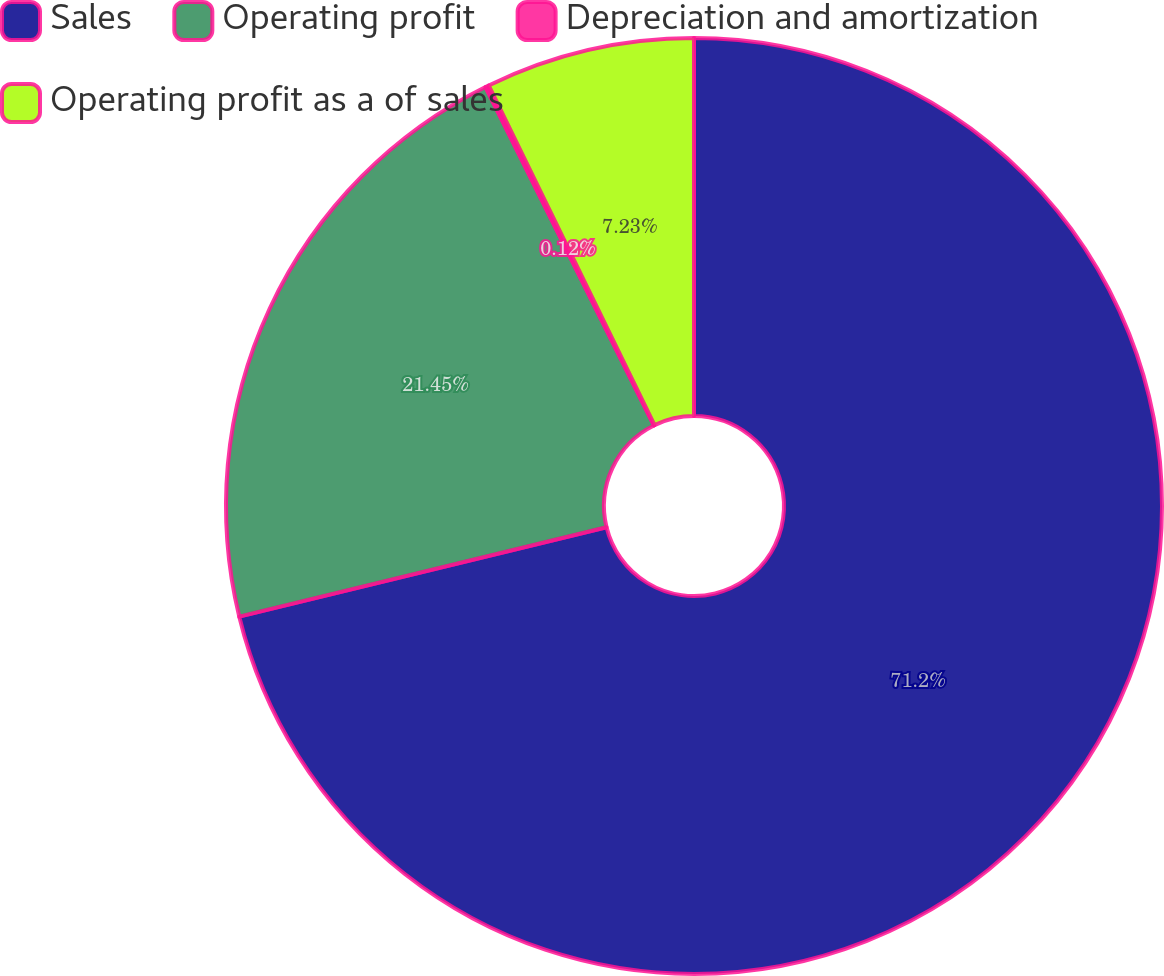<chart> <loc_0><loc_0><loc_500><loc_500><pie_chart><fcel>Sales<fcel>Operating profit<fcel>Depreciation and amortization<fcel>Operating profit as a of sales<nl><fcel>71.2%<fcel>21.45%<fcel>0.12%<fcel>7.23%<nl></chart> 